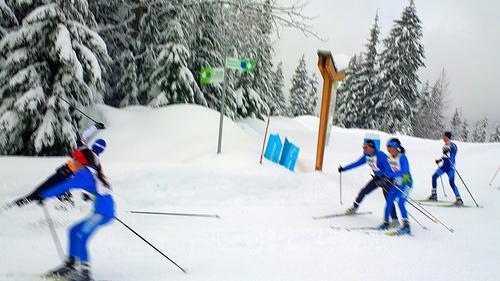How many people are skiing?
Give a very brief answer. 5. How many people have black pants?
Give a very brief answer. 2. 